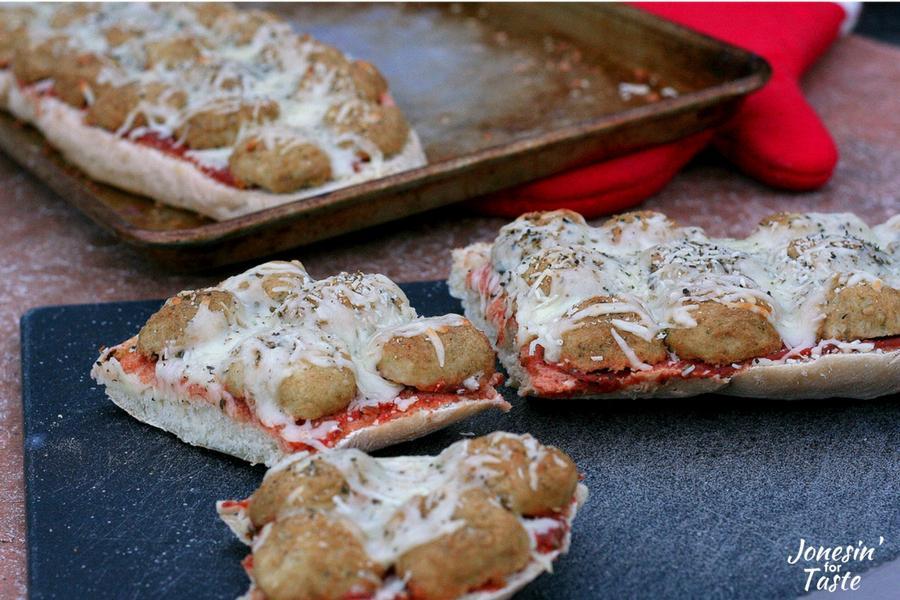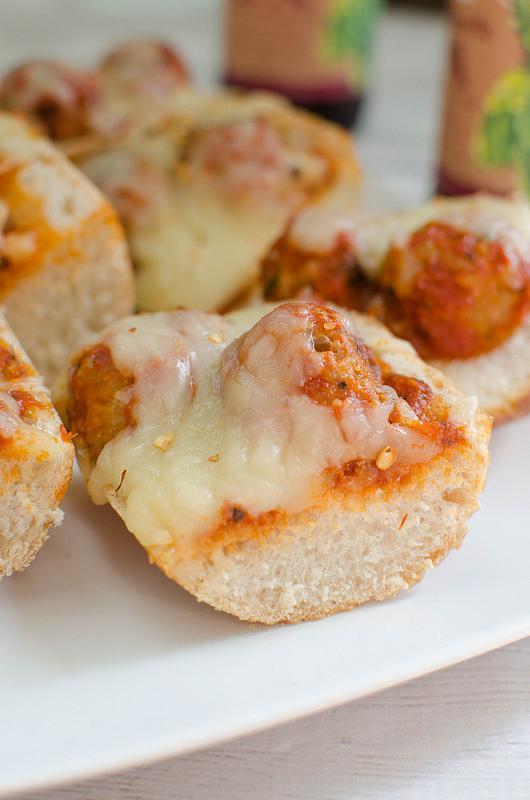The first image is the image on the left, the second image is the image on the right. Given the left and right images, does the statement "The pizza in both images is french bread pizza." hold true? Answer yes or no. Yes. 